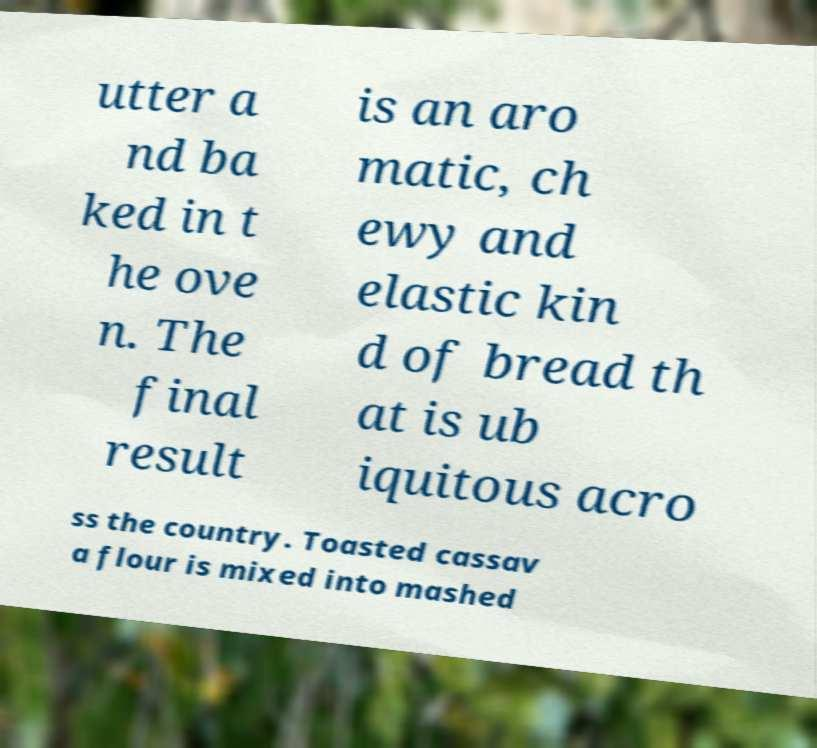Can you read and provide the text displayed in the image?This photo seems to have some interesting text. Can you extract and type it out for me? utter a nd ba ked in t he ove n. The final result is an aro matic, ch ewy and elastic kin d of bread th at is ub iquitous acro ss the country. Toasted cassav a flour is mixed into mashed 